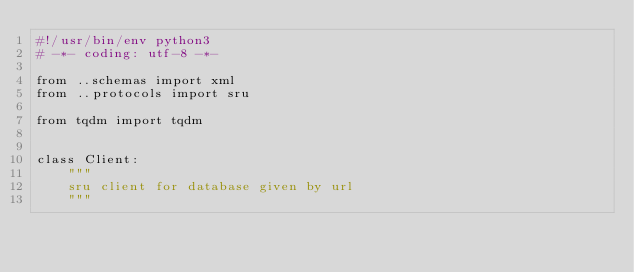Convert code to text. <code><loc_0><loc_0><loc_500><loc_500><_Python_>#!/usr/bin/env python3
# -*- coding: utf-8 -*-

from ..schemas import xml
from ..protocols import sru

from tqdm import tqdm


class Client:
    """
    sru client for database given by url
    """
</code> 